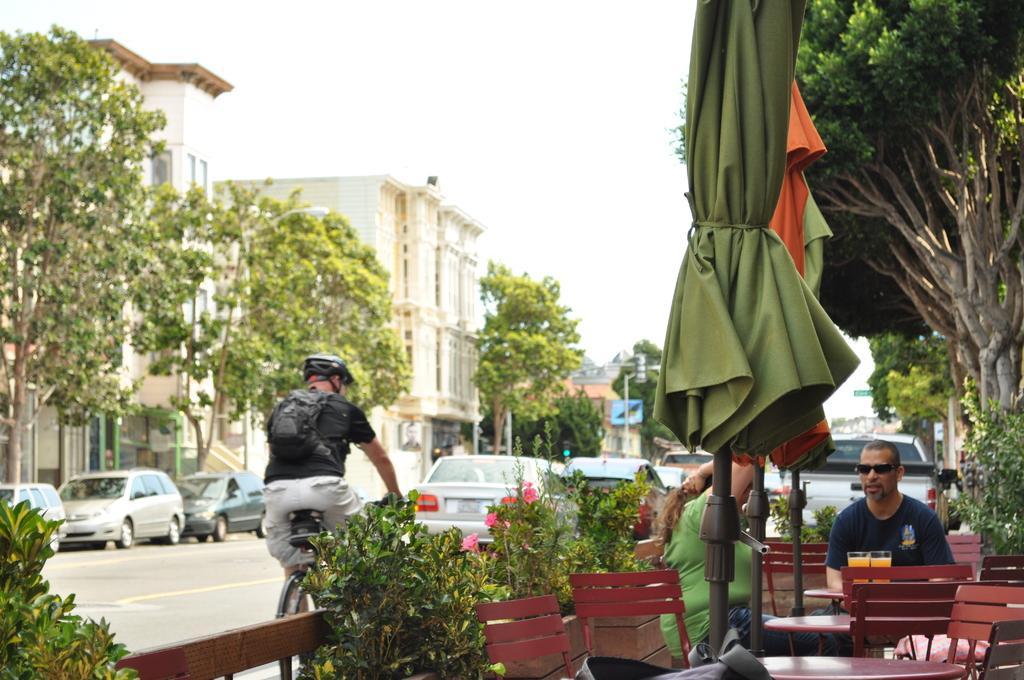Please provide a concise description of this image. In this image there are buildings, vehicles, plants, chairs, tables, road, people, sky, trees and objects. Among them two people are sitting on chairs and in-front of them there is a table, on that table there are glasses. Another person is sitting on a bicycle, wearing a helmet and bag.   